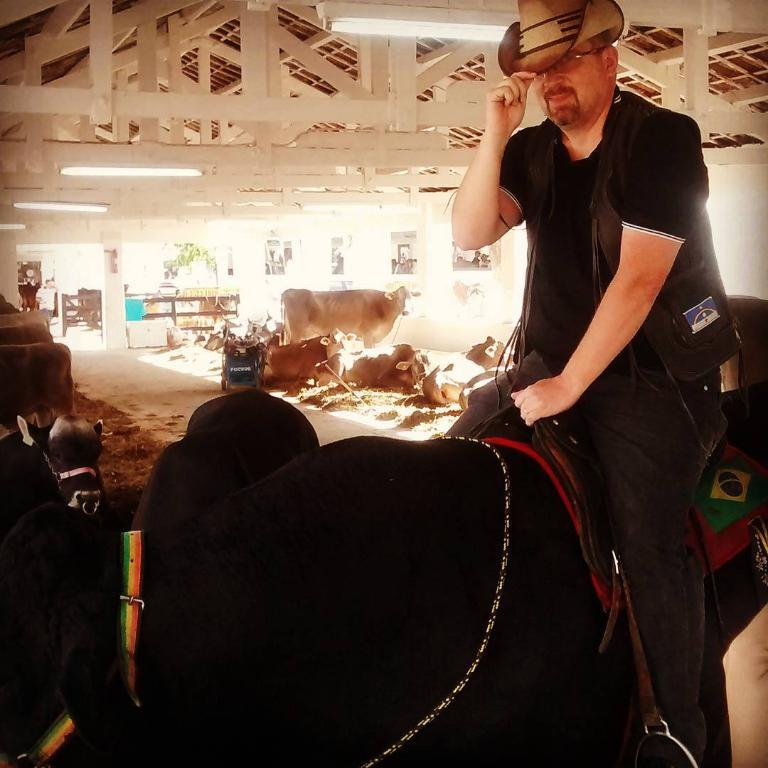What type of animals are in the image? There are cattle in the image. What are the cattle doing in the image? The cattle are sitting and lying on the ground, with one of them sitting on the others. What can be seen in the background of the image? There are wooden grills, electric lights, windows, and trees visible in the background of the image. What type of quill is being used by the cattle to write a letter in the image? There is no quill or letter-writing activity present in the image; the cattle are sitting and lying on the ground. 